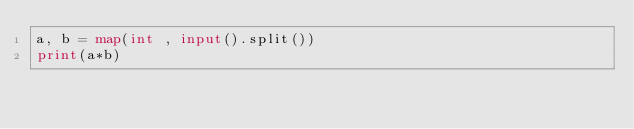<code> <loc_0><loc_0><loc_500><loc_500><_Python_>a, b = map(int , input().split())
print(a*b)</code> 